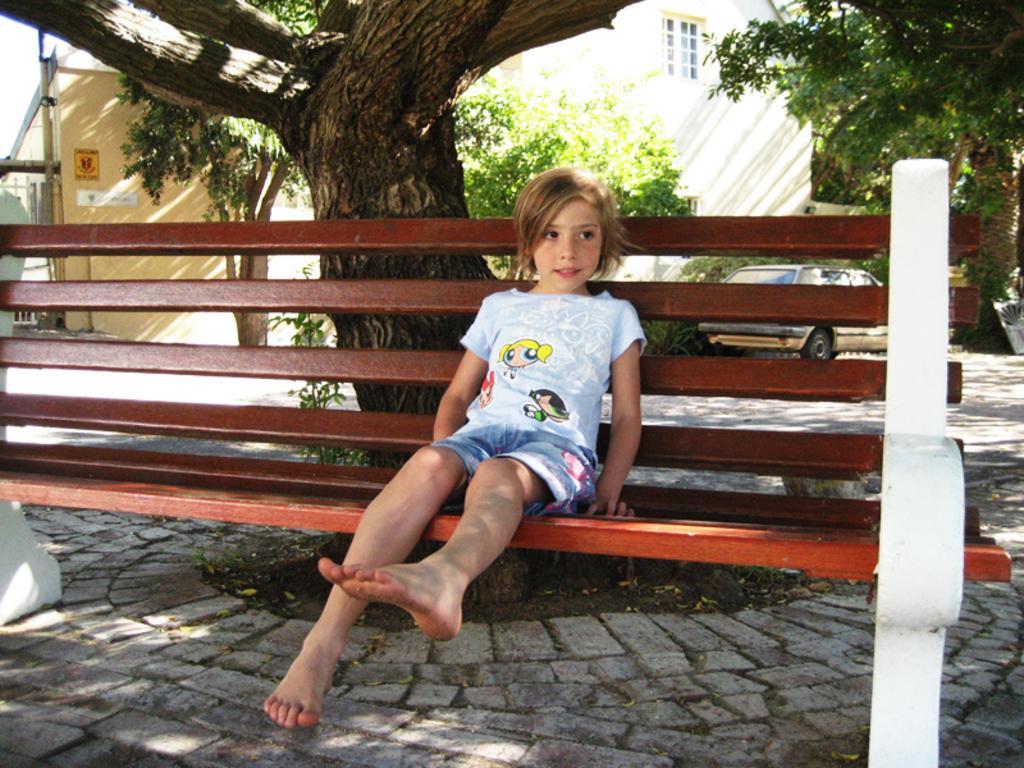Describe this image in one or two sentences. In this picture there is a girl sitting on the bench with bare foot. Behind her there is a tree, a building and there is a car parked on the road. The floor is of cobblestones. 